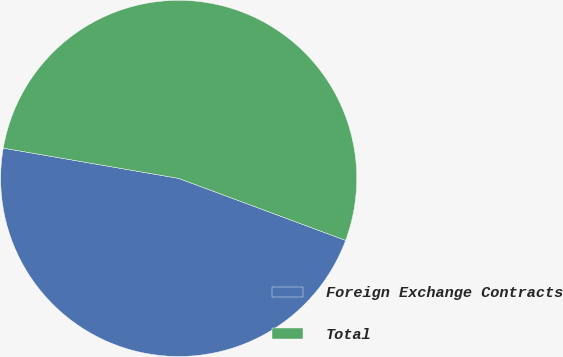<chart> <loc_0><loc_0><loc_500><loc_500><pie_chart><fcel>Foreign Exchange Contracts<fcel>Total<nl><fcel>47.06%<fcel>52.94%<nl></chart> 